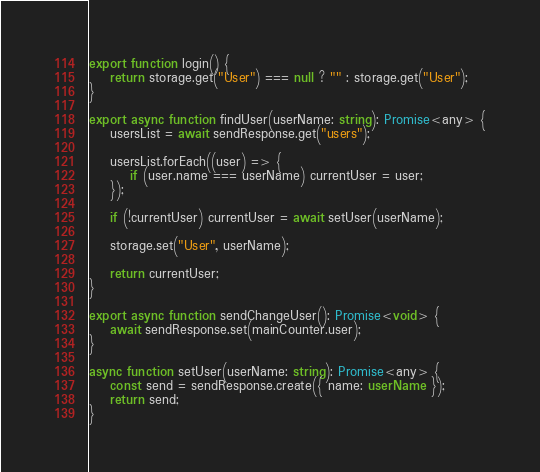<code> <loc_0><loc_0><loc_500><loc_500><_TypeScript_>
export function login() {
    return storage.get("User") === null ? "" : storage.get("User");
}

export async function findUser(userName: string): Promise<any> {
    usersList = await sendResponse.get("users");

    usersList.forEach((user) => {
        if (user.name === userName) currentUser = user;
    });

    if (!currentUser) currentUser = await setUser(userName);

    storage.set("User", userName);

    return currentUser;
}

export async function sendChangeUser(): Promise<void> {
    await sendResponse.set(mainCounter.user);
}

async function setUser(userName: string): Promise<any> {
    const send = sendResponse.create({ name: userName });
    return send;
}
</code> 